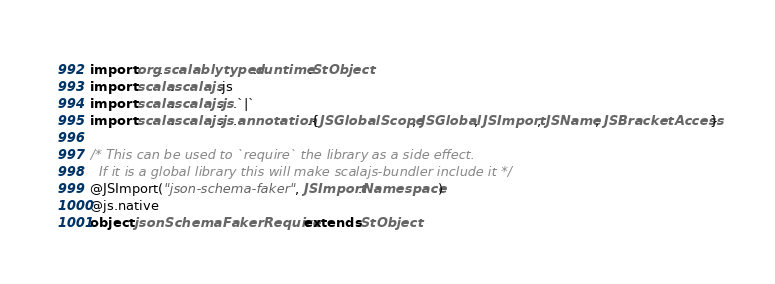Convert code to text. <code><loc_0><loc_0><loc_500><loc_500><_Scala_>import org.scalablytyped.runtime.StObject
import scala.scalajs.js
import scala.scalajs.js.`|`
import scala.scalajs.js.annotation.{JSGlobalScope, JSGlobal, JSImport, JSName, JSBracketAccess}

/* This can be used to `require` the library as a side effect.
  If it is a global library this will make scalajs-bundler include it */
@JSImport("json-schema-faker", JSImport.Namespace)
@js.native
object jsonSchemaFakerRequire extends StObject
</code> 